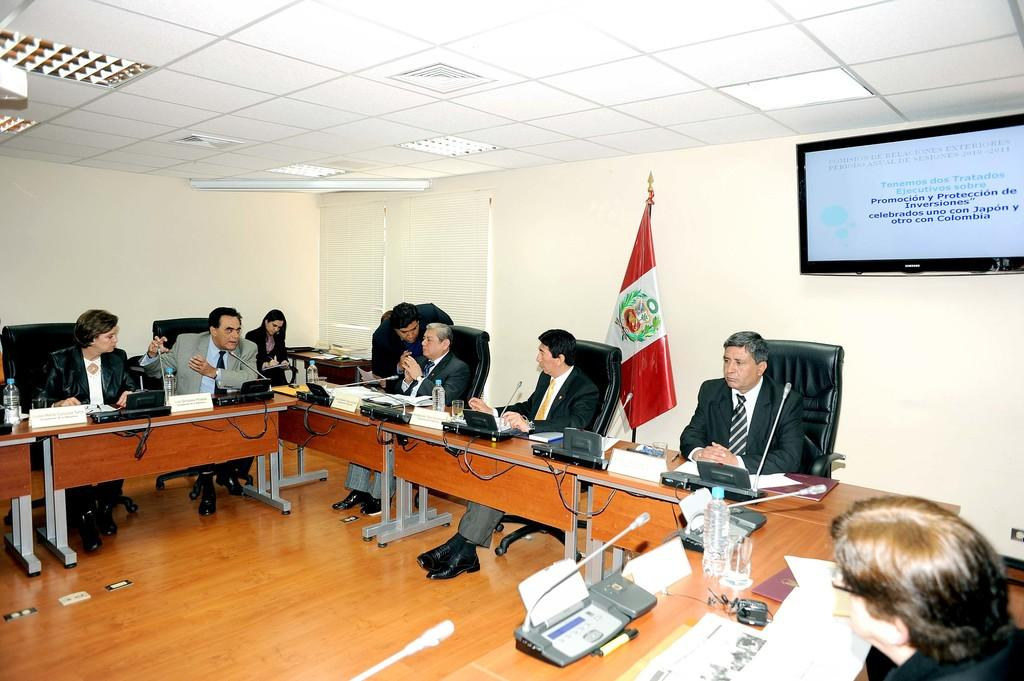What are the people in the image doing? The people in the image are sitting on chairs and discussing something. What can be seen on the wall in the image? There is a television fixed to a wall in the image. Is there any symbol or emblem present in the image? Yes, there is a flag in the image. What type of reaction does the grandmother have when she sees the flag in the image? There is no grandmother present in the image, so it is not possible to determine her reaction to the flag. 